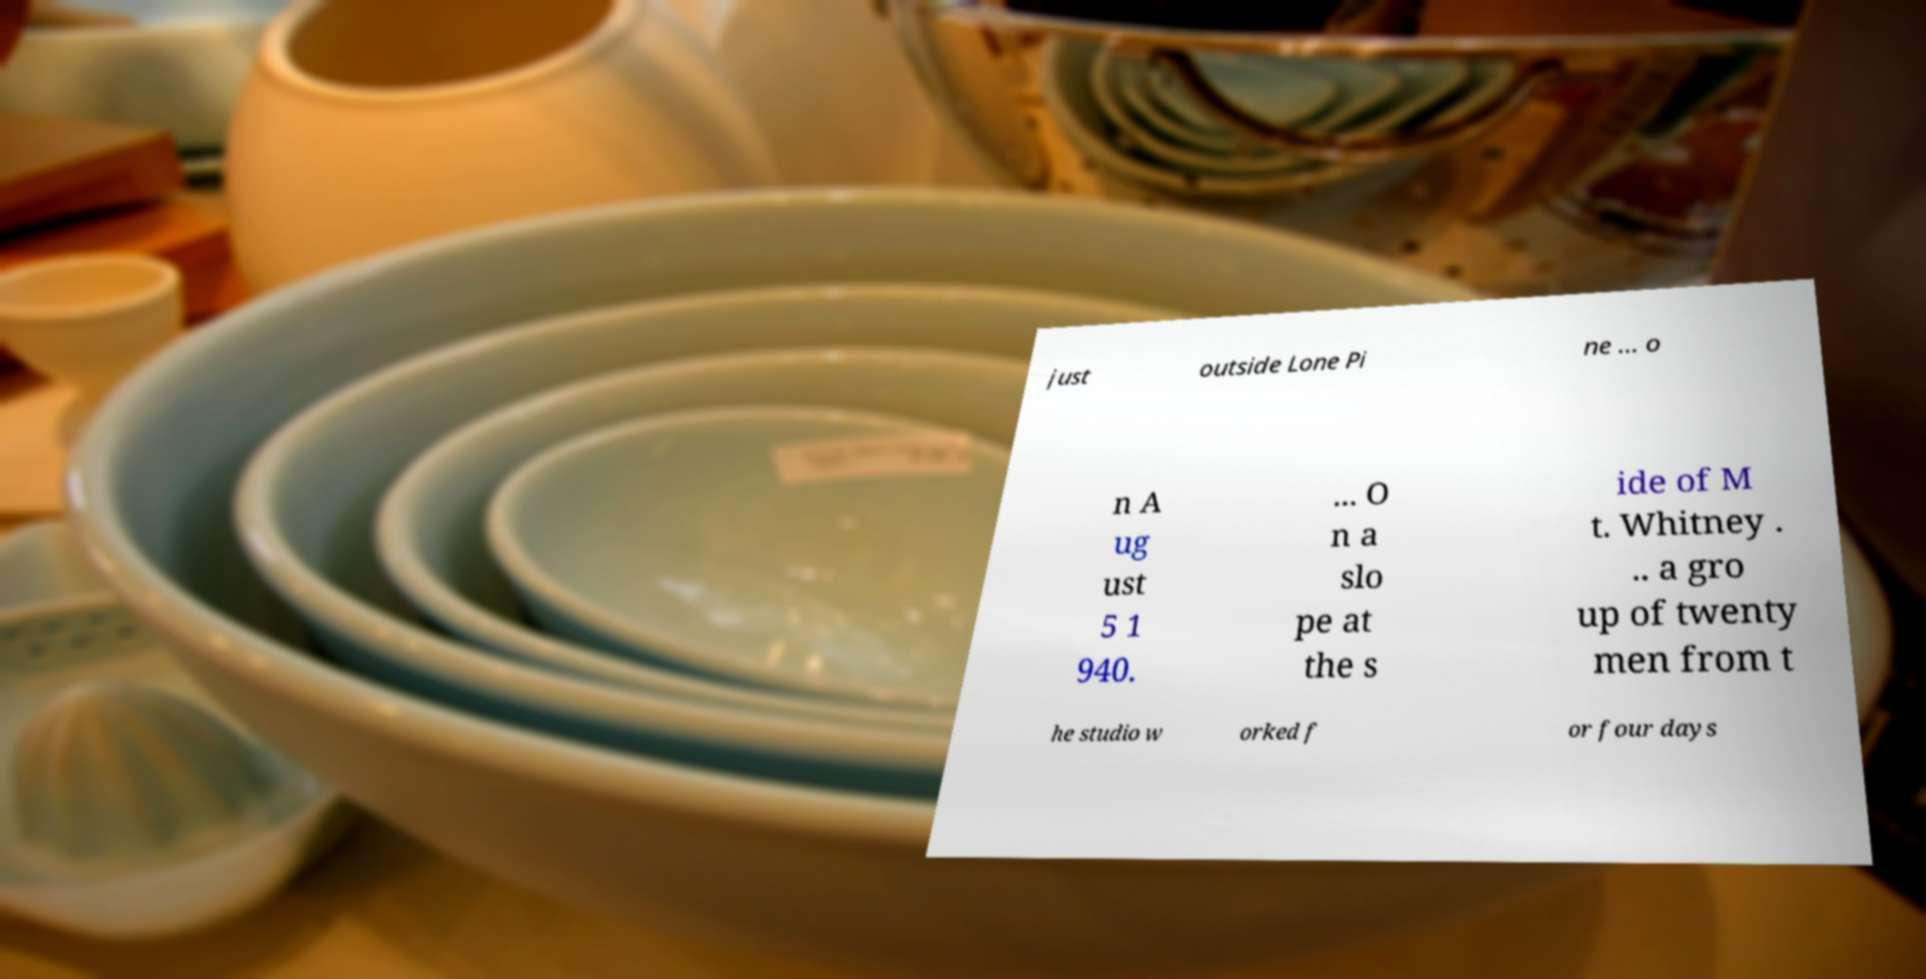Can you read and provide the text displayed in the image?This photo seems to have some interesting text. Can you extract and type it out for me? just outside Lone Pi ne ... o n A ug ust 5 1 940. ... O n a slo pe at the s ide of M t. Whitney . .. a gro up of twenty men from t he studio w orked f or four days 